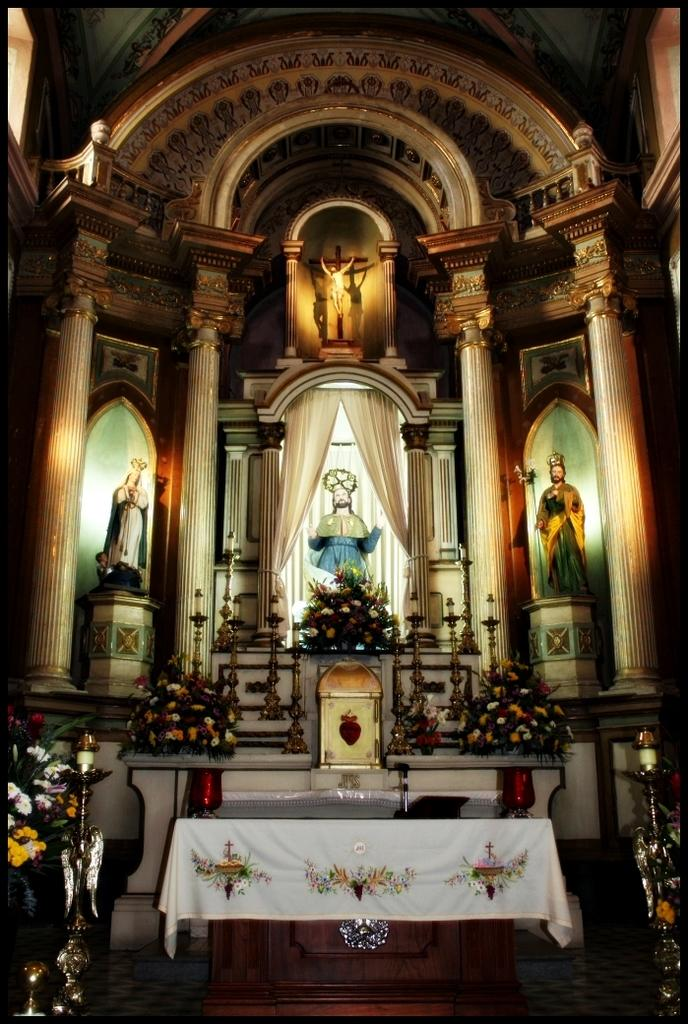Where was the image taken? The image was taken inside a church. What objects can be seen on a table in the image? There are flower vases on a table in the image. What is present in the image besides the flower vases? There is a statue in the image. Where are the flower vases located in relation to the statue? The flower vases are in front of the statue. What architectural feature can be seen in the image? There is a window with a curtain in the image. What type of muscle can be seen flexing in the image? There is no muscle visible in the image; it was taken inside a church and features flower vases, a statue, and a window with a curtain. 